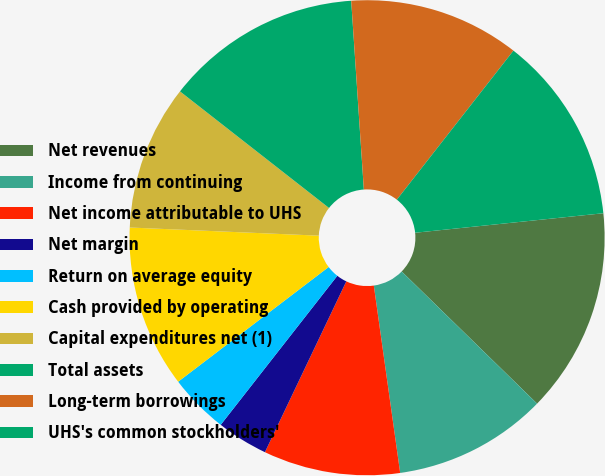Convert chart. <chart><loc_0><loc_0><loc_500><loc_500><pie_chart><fcel>Net revenues<fcel>Income from continuing<fcel>Net income attributable to UHS<fcel>Net margin<fcel>Return on average equity<fcel>Cash provided by operating<fcel>Capital expenditures net (1)<fcel>Total assets<fcel>Long-term borrowings<fcel>UHS's common stockholders'<nl><fcel>13.95%<fcel>10.47%<fcel>9.3%<fcel>3.49%<fcel>4.07%<fcel>11.05%<fcel>9.88%<fcel>13.37%<fcel>11.63%<fcel>12.79%<nl></chart> 